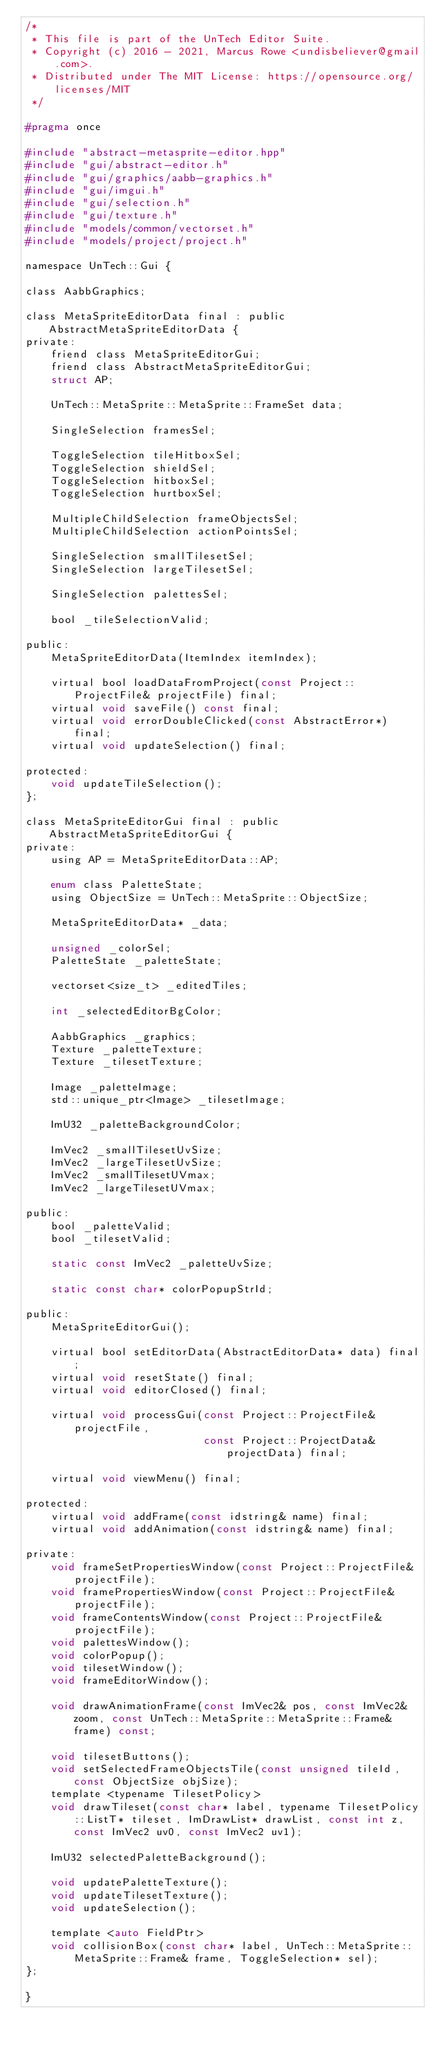Convert code to text. <code><loc_0><loc_0><loc_500><loc_500><_C_>/*
 * This file is part of the UnTech Editor Suite.
 * Copyright (c) 2016 - 2021, Marcus Rowe <undisbeliever@gmail.com>.
 * Distributed under The MIT License: https://opensource.org/licenses/MIT
 */

#pragma once

#include "abstract-metasprite-editor.hpp"
#include "gui/abstract-editor.h"
#include "gui/graphics/aabb-graphics.h"
#include "gui/imgui.h"
#include "gui/selection.h"
#include "gui/texture.h"
#include "models/common/vectorset.h"
#include "models/project/project.h"

namespace UnTech::Gui {

class AabbGraphics;

class MetaSpriteEditorData final : public AbstractMetaSpriteEditorData {
private:
    friend class MetaSpriteEditorGui;
    friend class AbstractMetaSpriteEditorGui;
    struct AP;

    UnTech::MetaSprite::MetaSprite::FrameSet data;

    SingleSelection framesSel;

    ToggleSelection tileHitboxSel;
    ToggleSelection shieldSel;
    ToggleSelection hitboxSel;
    ToggleSelection hurtboxSel;

    MultipleChildSelection frameObjectsSel;
    MultipleChildSelection actionPointsSel;

    SingleSelection smallTilesetSel;
    SingleSelection largeTilesetSel;

    SingleSelection palettesSel;

    bool _tileSelectionValid;

public:
    MetaSpriteEditorData(ItemIndex itemIndex);

    virtual bool loadDataFromProject(const Project::ProjectFile& projectFile) final;
    virtual void saveFile() const final;
    virtual void errorDoubleClicked(const AbstractError*) final;
    virtual void updateSelection() final;

protected:
    void updateTileSelection();
};

class MetaSpriteEditorGui final : public AbstractMetaSpriteEditorGui {
private:
    using AP = MetaSpriteEditorData::AP;

    enum class PaletteState;
    using ObjectSize = UnTech::MetaSprite::ObjectSize;

    MetaSpriteEditorData* _data;

    unsigned _colorSel;
    PaletteState _paletteState;

    vectorset<size_t> _editedTiles;

    int _selectedEditorBgColor;

    AabbGraphics _graphics;
    Texture _paletteTexture;
    Texture _tilesetTexture;

    Image _paletteImage;
    std::unique_ptr<Image> _tilesetImage;

    ImU32 _paletteBackgroundColor;

    ImVec2 _smallTilesetUvSize;
    ImVec2 _largeTilesetUvSize;
    ImVec2 _smallTilesetUVmax;
    ImVec2 _largeTilesetUVmax;

public:
    bool _paletteValid;
    bool _tilesetValid;

    static const ImVec2 _paletteUvSize;

    static const char* colorPopupStrId;

public:
    MetaSpriteEditorGui();

    virtual bool setEditorData(AbstractEditorData* data) final;
    virtual void resetState() final;
    virtual void editorClosed() final;

    virtual void processGui(const Project::ProjectFile& projectFile,
                            const Project::ProjectData& projectData) final;

    virtual void viewMenu() final;

protected:
    virtual void addFrame(const idstring& name) final;
    virtual void addAnimation(const idstring& name) final;

private:
    void frameSetPropertiesWindow(const Project::ProjectFile& projectFile);
    void framePropertiesWindow(const Project::ProjectFile& projectFile);
    void frameContentsWindow(const Project::ProjectFile& projectFile);
    void palettesWindow();
    void colorPopup();
    void tilesetWindow();
    void frameEditorWindow();

    void drawAnimationFrame(const ImVec2& pos, const ImVec2& zoom, const UnTech::MetaSprite::MetaSprite::Frame& frame) const;

    void tilesetButtons();
    void setSelectedFrameObjectsTile(const unsigned tileId, const ObjectSize objSize);
    template <typename TilesetPolicy>
    void drawTileset(const char* label, typename TilesetPolicy::ListT* tileset, ImDrawList* drawList, const int z, const ImVec2 uv0, const ImVec2 uv1);

    ImU32 selectedPaletteBackground();

    void updatePaletteTexture();
    void updateTilesetTexture();
    void updateSelection();

    template <auto FieldPtr>
    void collisionBox(const char* label, UnTech::MetaSprite::MetaSprite::Frame& frame, ToggleSelection* sel);
};

}
</code> 